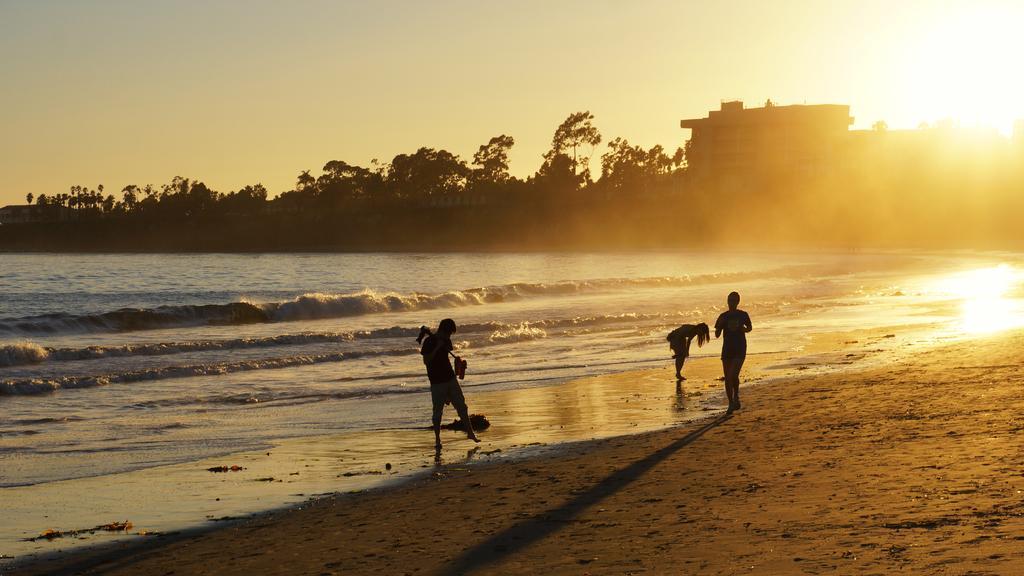Could you give a brief overview of what you see in this image? In the foreground of this image, there are three people standing on the sand. In the background, there is water, trees, buildings, sun and the sky. 